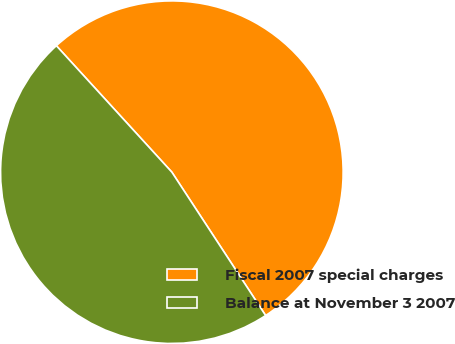Convert chart. <chart><loc_0><loc_0><loc_500><loc_500><pie_chart><fcel>Fiscal 2007 special charges<fcel>Balance at November 3 2007<nl><fcel>52.56%<fcel>47.44%<nl></chart> 